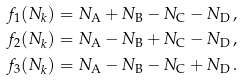<formula> <loc_0><loc_0><loc_500><loc_500>f _ { 1 } ( N _ { k } ) = N _ { \text {A} } + N _ { \text {B} } - N _ { \text {C} } - N _ { \text {D} } \, , \\ f _ { 2 } ( N _ { k } ) = N _ { \text {A} } - N _ { \text {B} } + N _ { \text {C} } - N _ { \text {D} } \, , \\ f _ { 3 } ( N _ { k } ) = N _ { \text {A} } - N _ { \text {B} } - N _ { \text {C} } + N _ { \text {D} } \, .</formula> 